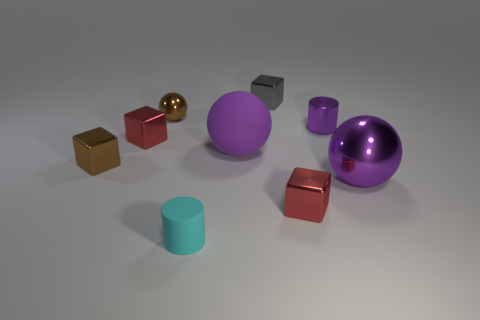Add 1 tiny cyan metal cylinders. How many objects exist? 10 Subtract all spheres. How many objects are left? 6 Subtract all small brown metallic cylinders. Subtract all small brown metallic things. How many objects are left? 7 Add 3 red metal things. How many red metal things are left? 5 Add 1 small red things. How many small red things exist? 3 Subtract 0 red cylinders. How many objects are left? 9 